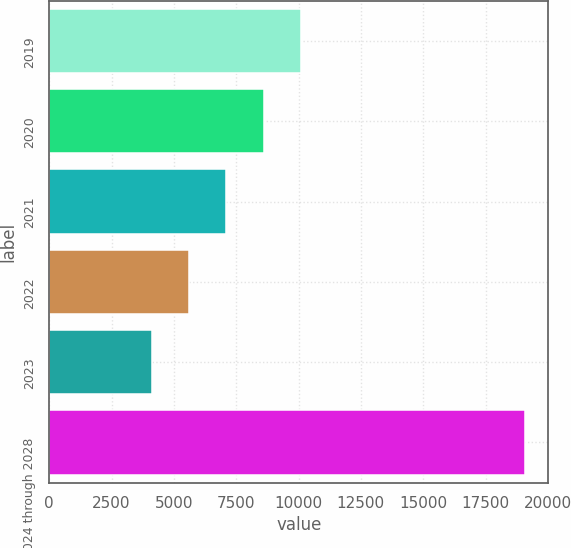Convert chart to OTSL. <chart><loc_0><loc_0><loc_500><loc_500><bar_chart><fcel>2019<fcel>2020<fcel>2021<fcel>2022<fcel>2023<fcel>2024 through 2028<nl><fcel>10090.8<fcel>8595.1<fcel>7099.4<fcel>5603.7<fcel>4108<fcel>19065<nl></chart> 